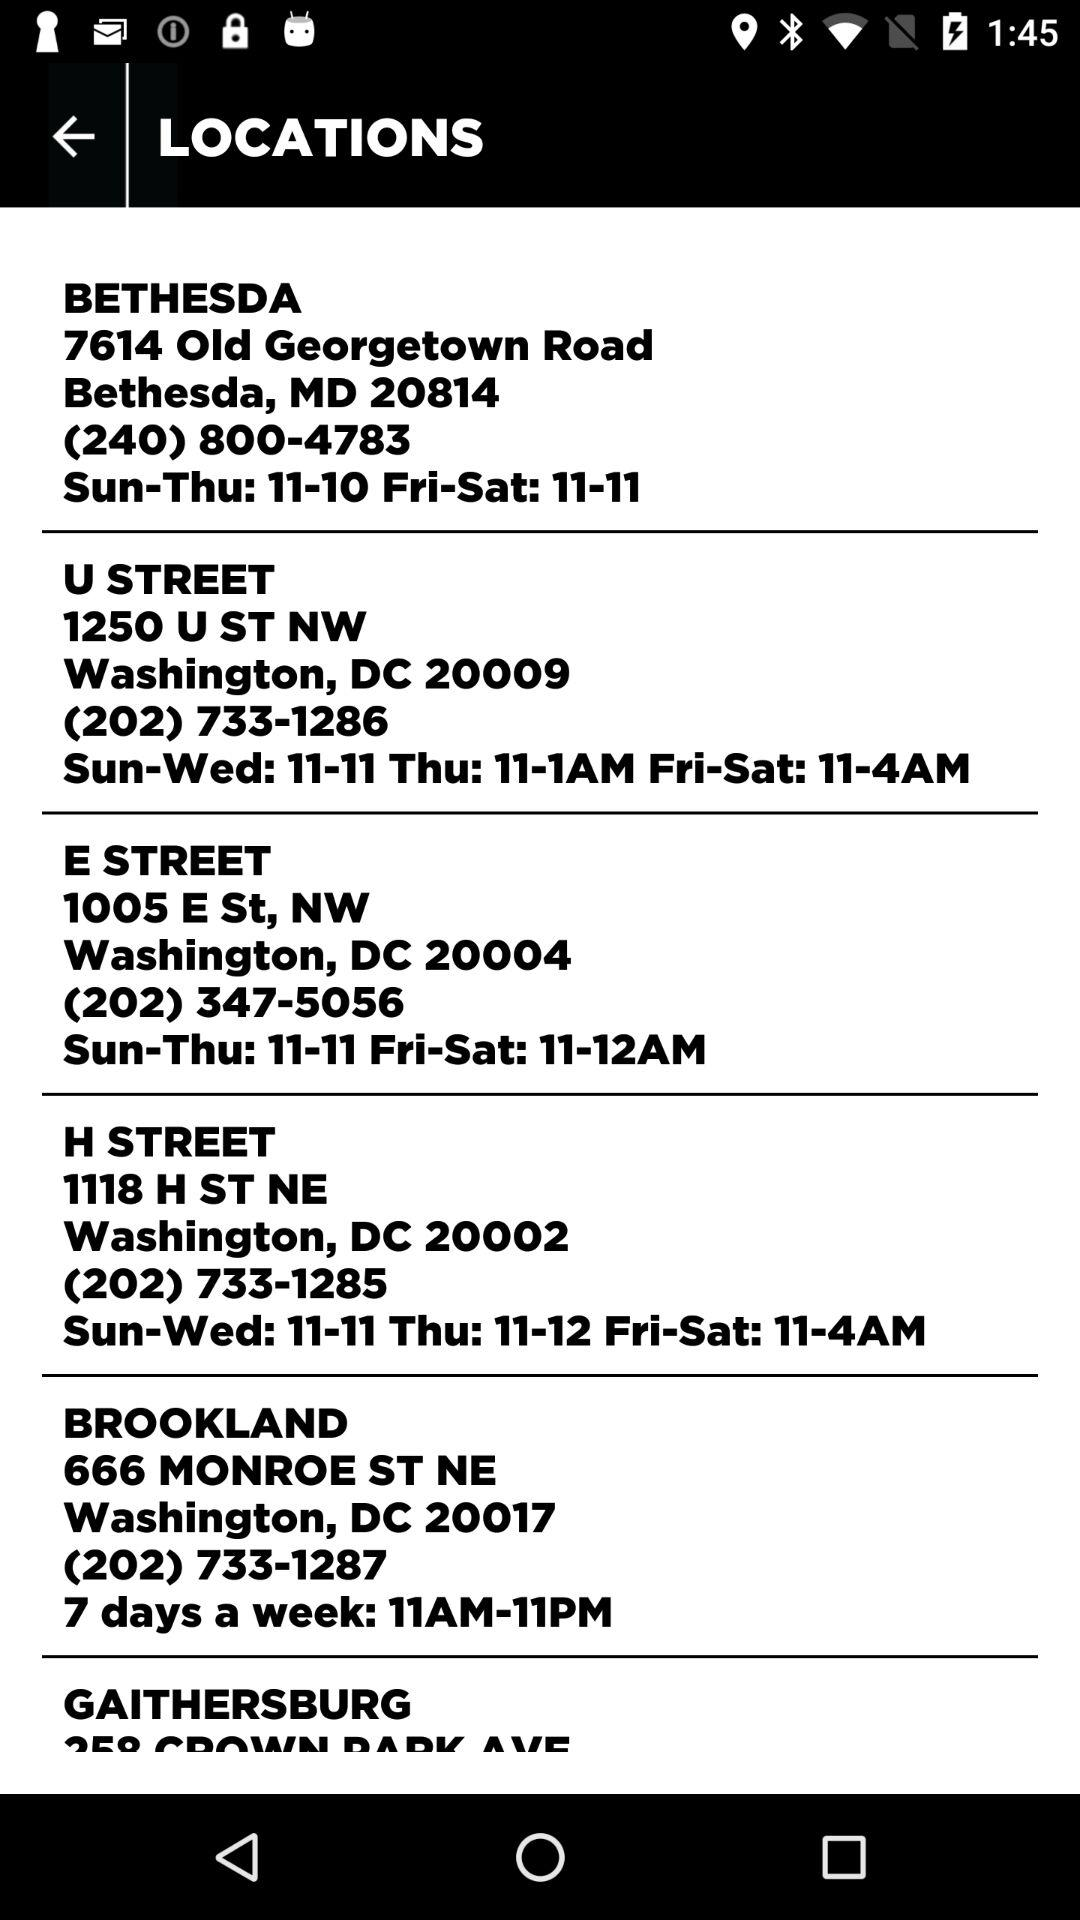What are the mentioned days and timings?
When the provided information is insufficient, respond with <no answer>. <no answer> 